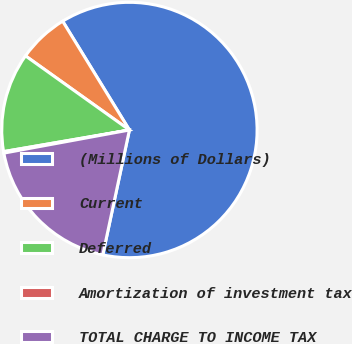Convert chart to OTSL. <chart><loc_0><loc_0><loc_500><loc_500><pie_chart><fcel>(Millions of Dollars)<fcel>Current<fcel>Deferred<fcel>Amortization of investment tax<fcel>TOTAL CHARGE TO INCOME TAX<nl><fcel>62.11%<fcel>6.38%<fcel>12.57%<fcel>0.19%<fcel>18.76%<nl></chart> 